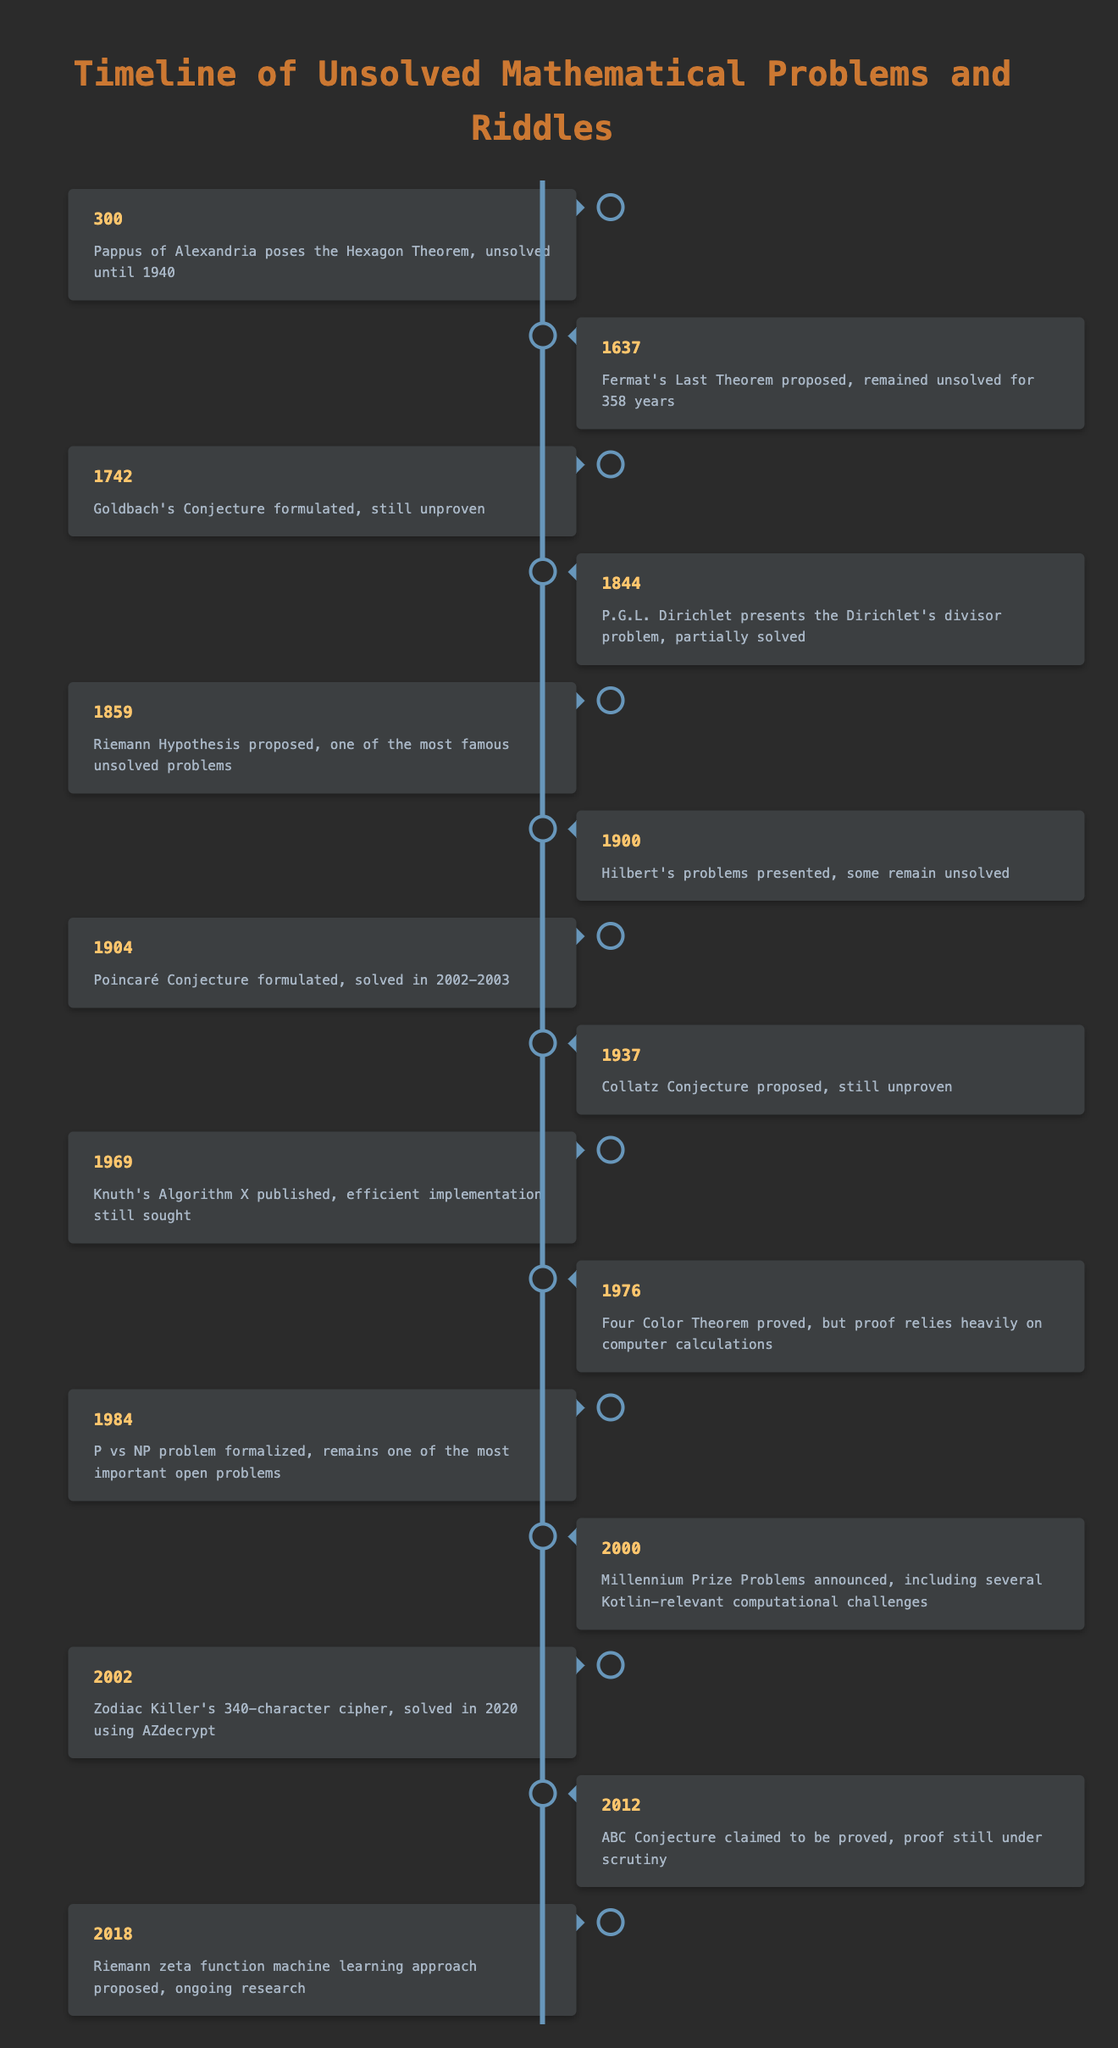What year was Fermat's Last Theorem proposed? The table specifies that Fermat's Last Theorem was proposed in the year 1637. Looking for the entry that mentions Fermat's Last Theorem, the corresponding year is clearly listed next to it.
Answer: 1637 Which of the following conjectures remains unproven: Goldbach's Conjecture or Collatz Conjecture? The table indicates that both Goldbach's Conjecture and Collatz Conjecture are still unproven. Therefore, either answer is correct. From the entries for Goldbach's Conjecture (1742) and Collatz Conjecture (1937), it's clear they both remain outstanding issues in mathematics.
Answer: Both Goldbach's Conjecture and Collatz Conjecture remain unproven When was the Riemann Hypothesis proposed? The Riemann Hypothesis is specifically noted as having been proposed in 1859 in the table. This information can be located by scanning for the entry mentioning the Riemann Hypothesis.
Answer: 1859 How many years did Fermat's Last Theorem remain unsolved? Fermat's Last Theorem was proposed in 1637 and remained unsolved for 358 years. To find the total duration, we subtract the year it was proposed from the year it was solved, which is 1995 (1637 + 358 = 1995, when it was finally proven). This calculation confirms the number of years it remained unsolved.
Answer: 358 years Is the Four Color Theorem proven? The table mentions that the Four Color Theorem was proved, thus indicating it is no longer an open problem. To verify, I can refer to the entry for the Four Color Theorem and note its solved status.
Answer: Yes Which unsolved problem was formulated in 1937? The table specifies that the Collatz Conjecture was proposed in the year 1937. I can find this information by looking for the event that lists the year as 1937, which explicitly states it is the Collatz Conjecture.
Answer: Collatz Conjecture What conjecture was claimed to be proved in 2012? According to the table, the ABC Conjecture claimed to be proved in 2012 but its proof is still under scrutiny. This can be identified by locating the entry that corresponds to the year 2012 and checking the associated event.
Answer: ABC Conjecture How many events in the timeline are related to the Riemann Hypothesis? There are two mentions related to the Riemann Hypothesis in the table: it was proposed in 1859 and in 2018, a machine learning approach concerning the Riemann zeta function (which relates to the hypothesis) was proposed. Thus, I count two entries associated with the overarching topic of the Riemann Hypothesis.
Answer: 2 events In which year did the Zodiac killer's cipher get solved, and which method was used? The table states that the Zodiac Killer's 340-character cipher was solved in 2020 using AZdecrypt. To find this, I note the entry with the year 2002 (when the cipher was presented) and look for the entry that notes the solution year of 2020, where AZdecrypt is mentioned as the solving method.
Answer: 2020 using AZdecrypt 